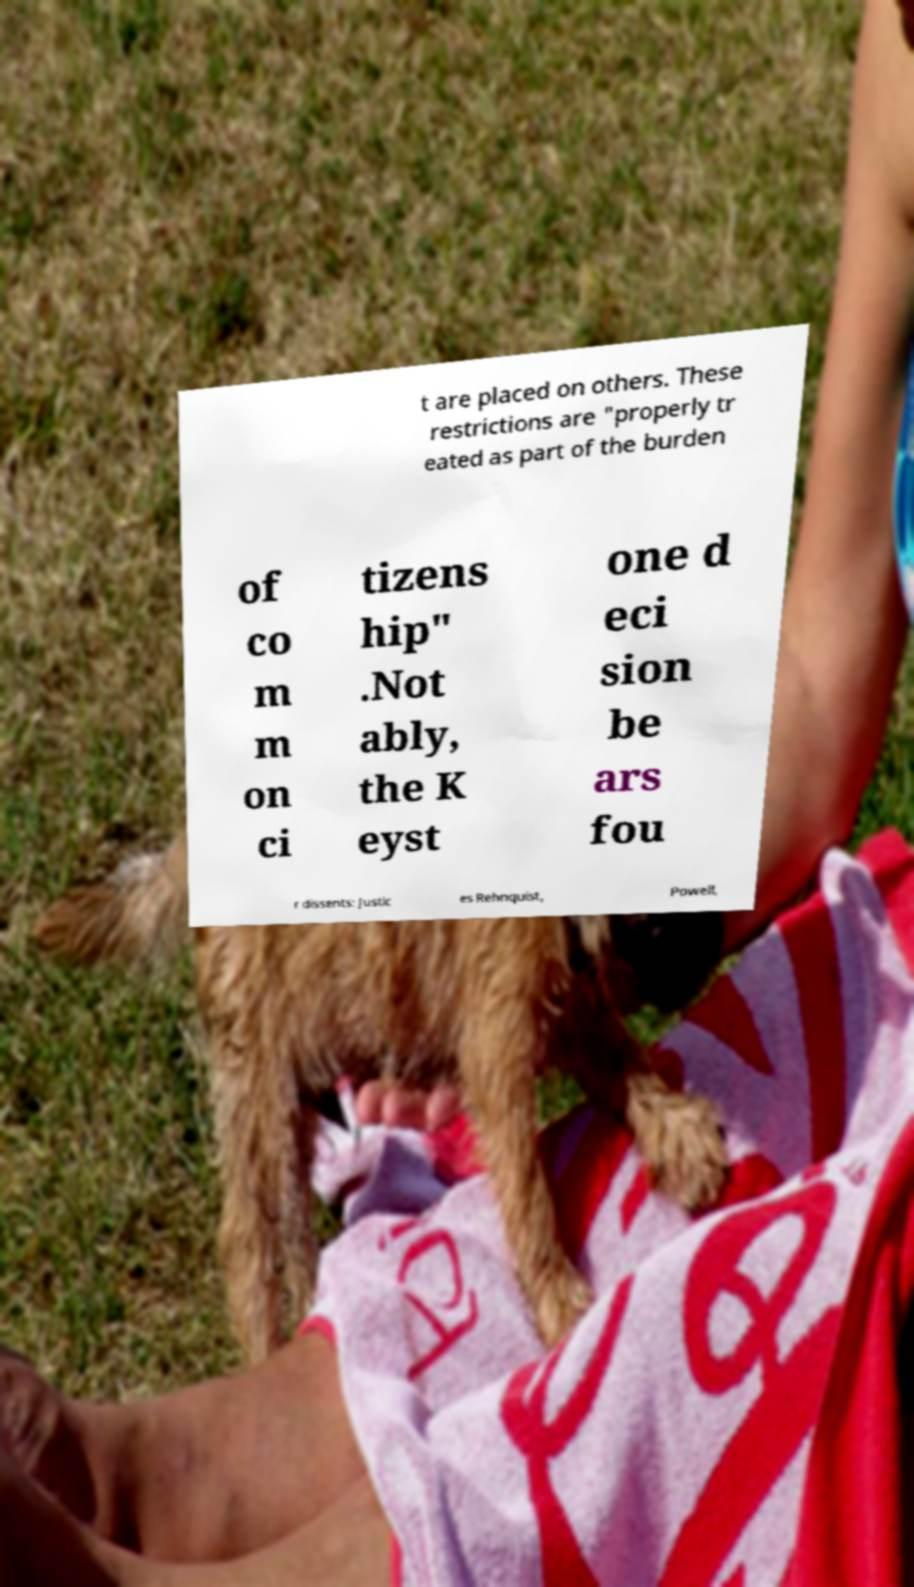Please identify and transcribe the text found in this image. t are placed on others. These restrictions are "properly tr eated as part of the burden of co m m on ci tizens hip" .Not ably, the K eyst one d eci sion be ars fou r dissents: Justic es Rehnquist, Powell, 